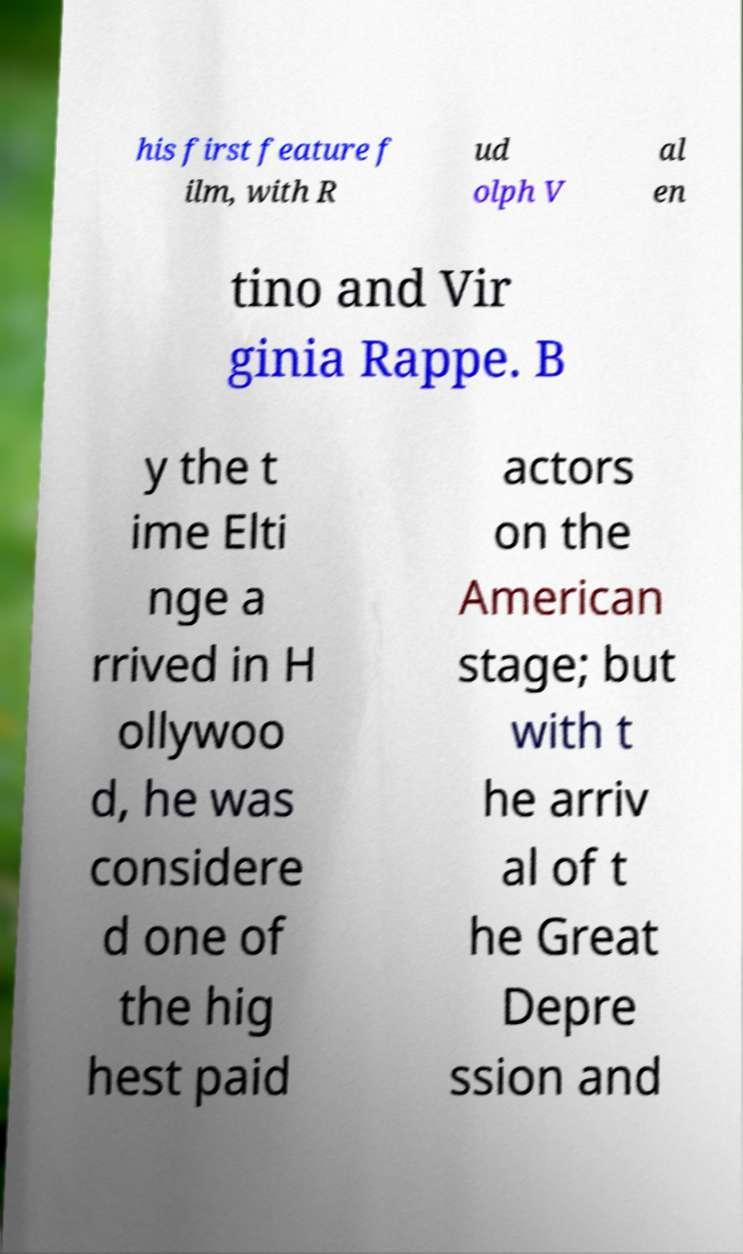There's text embedded in this image that I need extracted. Can you transcribe it verbatim? his first feature f ilm, with R ud olph V al en tino and Vir ginia Rappe. B y the t ime Elti nge a rrived in H ollywoo d, he was considere d one of the hig hest paid actors on the American stage; but with t he arriv al of t he Great Depre ssion and 